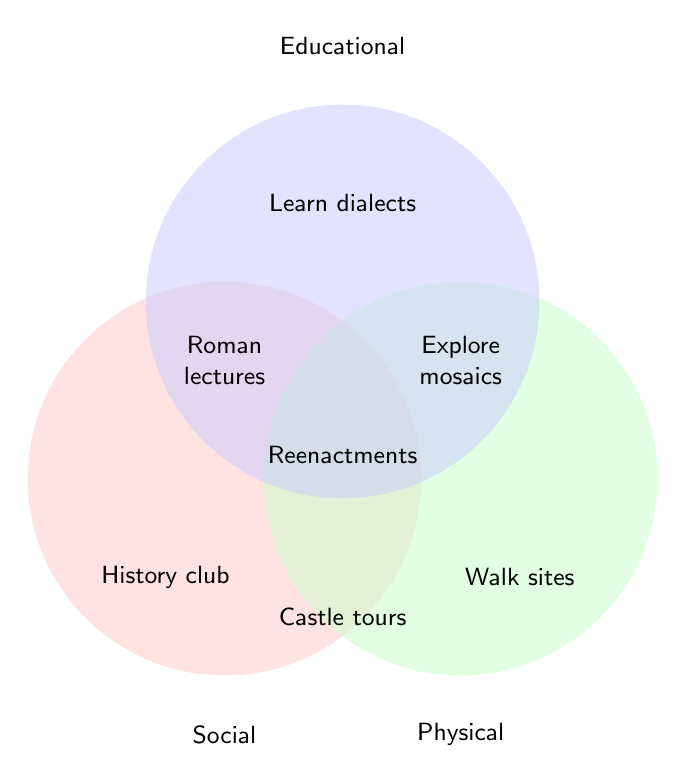Which activity is unique to the Social category? The activity that falls exclusively in the Social category is present in the segment that corresponds to only the Social circle in the Venn diagram.
Answer: Join local history club Which activities are in both the Social and Physical categories? These are the activities located in the overlapping section of the Social and Physical circles of the Venn diagram.
Answer: Group tours of medieval castles Is "Take Italian cooking classes" an activity in the Physical category? The activity "Take Italian cooking classes" is located within the Educational category, which does not intersect with the Physical circle.
Answer: No Which activities are common to all three categories: Social, Physical, and Educational? Look at the section where all three circles intersect; the activities there are part of all three categories.
Answer: Participate in historical reenactments How many activities are in the Physical category but not in the other two categories? Count the activities exclusive to the Physical section of the Venn diagram.
Answer: Three What category does "Explore Ravenna's mosaics on foot" belong to? The activity "Explore Ravenna's mosaics on foot" is in the intersection of the Physical and Educational circles.
Answer: Physical/Educational 